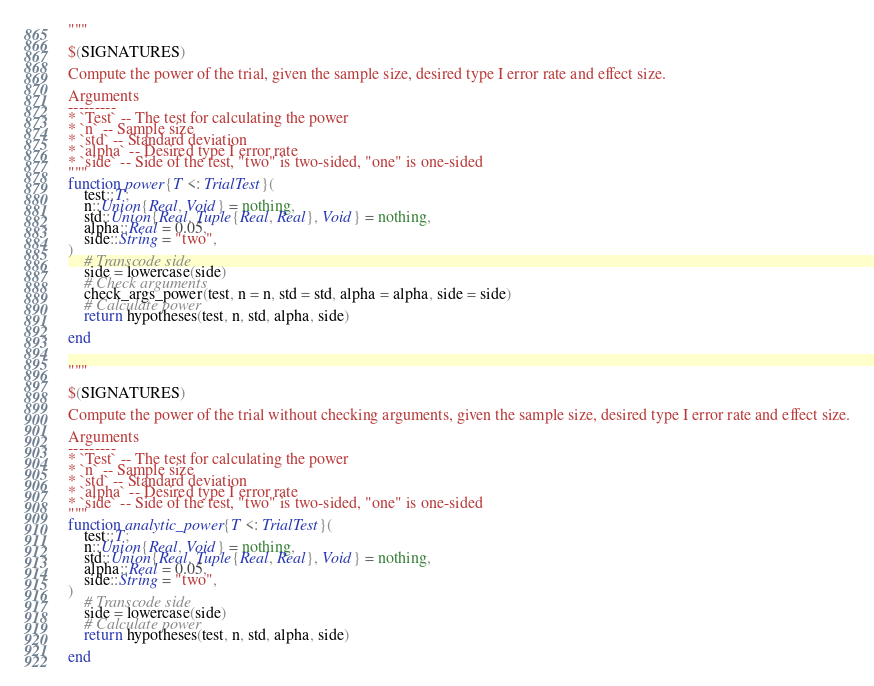<code> <loc_0><loc_0><loc_500><loc_500><_Julia_>"""

$(SIGNATURES)

Compute the power of the trial, given the sample size, desired type I error rate and effect size.

Arguments
---------
* `Test` -- The test for calculating the power
* `n` -- Sample size
* `std` -- Standard deviation
* `alpha` -- Desired type I error rate
* `side` -- Side of the test, "two" is two-sided, "one" is one-sided
"""
function power{T <: TrialTest}(
    test::T;
    n::Union{Real, Void} = nothing,
    std::Union{Real, Tuple{Real, Real}, Void} = nothing,
    alpha::Real = 0.05,
    side::String = "two",
)
    # Transcode side
    side = lowercase(side)
    # Check arguments
    check_args_power(test, n = n, std = std, alpha = alpha, side = side)
    # Calculate power
    return hypotheses(test, n, std, alpha, side)

end


"""

$(SIGNATURES)

Compute the power of the trial without checking arguments, given the sample size, desired type I error rate and effect size.

Arguments
---------
* `Test` -- The test for calculating the power
* `n` -- Sample size
* `std` -- Standard deviation
* `alpha` -- Desired type I error rate
* `side` -- Side of the test, "two" is two-sided, "one" is one-sided
"""
function analytic_power{T <: TrialTest}(
    test::T;
    n::Union{Real, Void} = nothing,
    std::Union{Real, Tuple{Real, Real}, Void} = nothing,
    alpha::Real = 0.05,
    side::String = "two",
)
    # Transcode side
    side = lowercase(side)
    # Calculate power
    return hypotheses(test, n, std, alpha, side)

end
</code> 